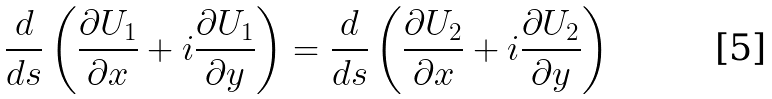<formula> <loc_0><loc_0><loc_500><loc_500>\frac { d } { d s } \left ( \frac { \partial U _ { 1 } } { \partial x } + i \frac { \partial U _ { 1 } } { \partial y } \right ) = \frac { d } { d s } \left ( \frac { \partial U _ { 2 } } { \partial x } + i \frac { \partial U _ { 2 } } { \partial y } \right )</formula> 